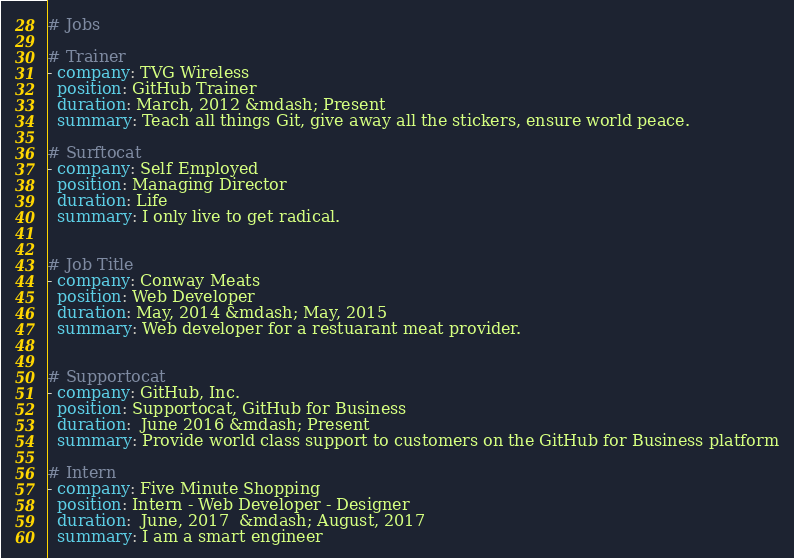<code> <loc_0><loc_0><loc_500><loc_500><_YAML_># Jobs

# Trainer
- company: TVG Wireless
  position: GitHub Trainer
  duration: March, 2012 &mdash; Present
  summary: Teach all things Git, give away all the stickers, ensure world peace.

# Surftocat
- company: Self Employed
  position: Managing Director
  duration: Life
  summary: I only live to get radical.


# Job Title
- company: Conway Meats
  position: Web Developer
  duration: May, 2014 &mdash; May, 2015
  summary: Web developer for a restuarant meat provider.


# Supportocat
- company: GitHub, Inc.
  position: Supportocat, GitHub for Business
  duration:  June 2016 &mdash; Present
  summary: Provide world class support to customers on the GitHub for Business platform

# Intern
- company: Five Minute Shopping
  position: Intern - Web Developer - Designer
  duration:  June, 2017  &mdash; August, 2017
  summary: I am a smart engineer 

</code> 